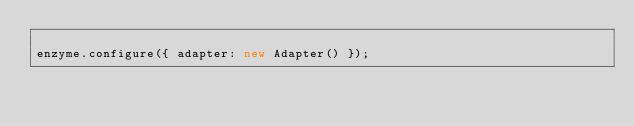<code> <loc_0><loc_0><loc_500><loc_500><_JavaScript_>
enzyme.configure({ adapter: new Adapter() });</code> 